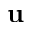<formula> <loc_0><loc_0><loc_500><loc_500>u</formula> 